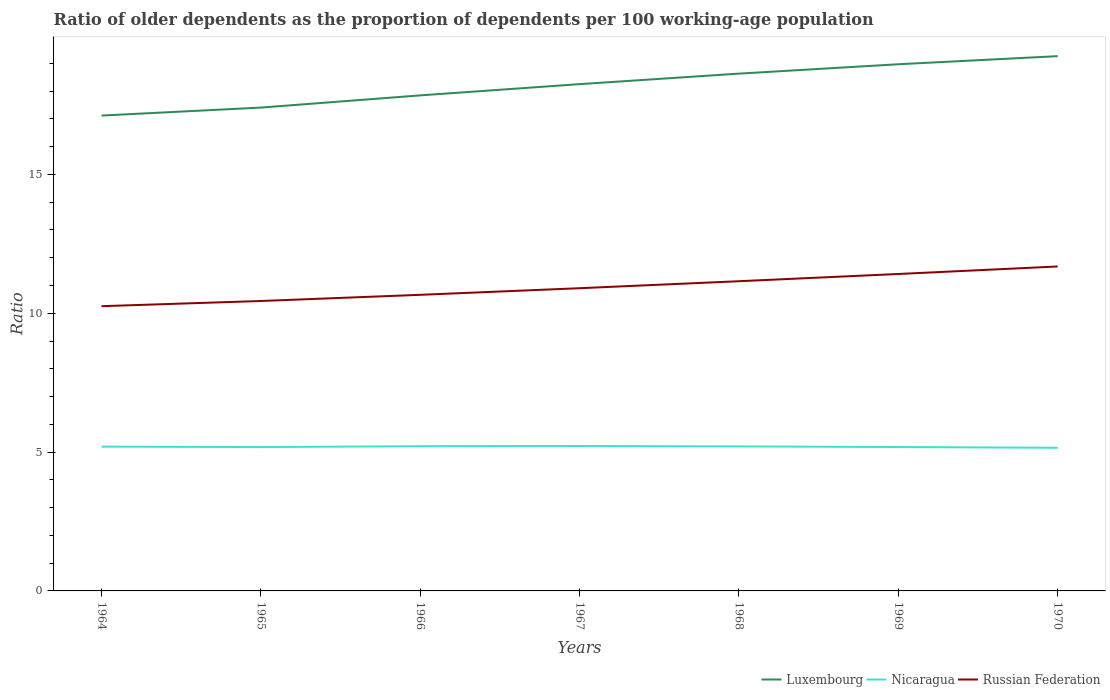How many different coloured lines are there?
Your response must be concise. 3. Does the line corresponding to Nicaragua intersect with the line corresponding to Russian Federation?
Your answer should be compact. No. Is the number of lines equal to the number of legend labels?
Give a very brief answer. Yes. Across all years, what is the maximum age dependency ratio(old) in Russian Federation?
Your answer should be compact. 10.25. In which year was the age dependency ratio(old) in Russian Federation maximum?
Offer a very short reply. 1964. What is the total age dependency ratio(old) in Nicaragua in the graph?
Keep it short and to the point. 0.03. What is the difference between the highest and the second highest age dependency ratio(old) in Luxembourg?
Keep it short and to the point. 2.14. What is the difference between the highest and the lowest age dependency ratio(old) in Russian Federation?
Ensure brevity in your answer.  3. How many lines are there?
Offer a very short reply. 3. What is the difference between two consecutive major ticks on the Y-axis?
Provide a short and direct response. 5. Where does the legend appear in the graph?
Your answer should be very brief. Bottom right. What is the title of the graph?
Your response must be concise. Ratio of older dependents as the proportion of dependents per 100 working-age population. Does "Congo (Democratic)" appear as one of the legend labels in the graph?
Give a very brief answer. No. What is the label or title of the Y-axis?
Offer a terse response. Ratio. What is the Ratio in Luxembourg in 1964?
Keep it short and to the point. 17.12. What is the Ratio of Nicaragua in 1964?
Offer a very short reply. 5.2. What is the Ratio of Russian Federation in 1964?
Make the answer very short. 10.25. What is the Ratio of Luxembourg in 1965?
Provide a succinct answer. 17.41. What is the Ratio of Nicaragua in 1965?
Provide a succinct answer. 5.18. What is the Ratio of Russian Federation in 1965?
Your answer should be compact. 10.44. What is the Ratio in Luxembourg in 1966?
Give a very brief answer. 17.85. What is the Ratio of Nicaragua in 1966?
Ensure brevity in your answer.  5.21. What is the Ratio of Russian Federation in 1966?
Give a very brief answer. 10.66. What is the Ratio in Luxembourg in 1967?
Ensure brevity in your answer.  18.25. What is the Ratio in Nicaragua in 1967?
Make the answer very short. 5.22. What is the Ratio in Russian Federation in 1967?
Offer a terse response. 10.9. What is the Ratio in Luxembourg in 1968?
Offer a very short reply. 18.63. What is the Ratio of Nicaragua in 1968?
Ensure brevity in your answer.  5.21. What is the Ratio in Russian Federation in 1968?
Provide a short and direct response. 11.15. What is the Ratio of Luxembourg in 1969?
Keep it short and to the point. 18.97. What is the Ratio of Nicaragua in 1969?
Give a very brief answer. 5.18. What is the Ratio of Russian Federation in 1969?
Keep it short and to the point. 11.41. What is the Ratio in Luxembourg in 1970?
Ensure brevity in your answer.  19.26. What is the Ratio in Nicaragua in 1970?
Ensure brevity in your answer.  5.16. What is the Ratio in Russian Federation in 1970?
Make the answer very short. 11.69. Across all years, what is the maximum Ratio of Luxembourg?
Make the answer very short. 19.26. Across all years, what is the maximum Ratio of Nicaragua?
Make the answer very short. 5.22. Across all years, what is the maximum Ratio of Russian Federation?
Your response must be concise. 11.69. Across all years, what is the minimum Ratio in Luxembourg?
Keep it short and to the point. 17.12. Across all years, what is the minimum Ratio in Nicaragua?
Keep it short and to the point. 5.16. Across all years, what is the minimum Ratio in Russian Federation?
Provide a succinct answer. 10.25. What is the total Ratio of Luxembourg in the graph?
Keep it short and to the point. 127.49. What is the total Ratio of Nicaragua in the graph?
Offer a very short reply. 36.35. What is the total Ratio of Russian Federation in the graph?
Your response must be concise. 76.52. What is the difference between the Ratio of Luxembourg in 1964 and that in 1965?
Keep it short and to the point. -0.29. What is the difference between the Ratio in Nicaragua in 1964 and that in 1965?
Ensure brevity in your answer.  0.02. What is the difference between the Ratio of Russian Federation in 1964 and that in 1965?
Offer a terse response. -0.19. What is the difference between the Ratio in Luxembourg in 1964 and that in 1966?
Offer a very short reply. -0.73. What is the difference between the Ratio of Nicaragua in 1964 and that in 1966?
Your response must be concise. -0.01. What is the difference between the Ratio of Russian Federation in 1964 and that in 1966?
Your response must be concise. -0.41. What is the difference between the Ratio in Luxembourg in 1964 and that in 1967?
Give a very brief answer. -1.13. What is the difference between the Ratio of Nicaragua in 1964 and that in 1967?
Keep it short and to the point. -0.02. What is the difference between the Ratio of Russian Federation in 1964 and that in 1967?
Your answer should be compact. -0.65. What is the difference between the Ratio of Luxembourg in 1964 and that in 1968?
Offer a terse response. -1.51. What is the difference between the Ratio of Nicaragua in 1964 and that in 1968?
Offer a terse response. -0.01. What is the difference between the Ratio in Russian Federation in 1964 and that in 1968?
Provide a short and direct response. -0.9. What is the difference between the Ratio of Luxembourg in 1964 and that in 1969?
Make the answer very short. -1.85. What is the difference between the Ratio of Nicaragua in 1964 and that in 1969?
Provide a succinct answer. 0.01. What is the difference between the Ratio in Russian Federation in 1964 and that in 1969?
Give a very brief answer. -1.16. What is the difference between the Ratio of Luxembourg in 1964 and that in 1970?
Your response must be concise. -2.14. What is the difference between the Ratio of Nicaragua in 1964 and that in 1970?
Offer a terse response. 0.04. What is the difference between the Ratio of Russian Federation in 1964 and that in 1970?
Your answer should be compact. -1.43. What is the difference between the Ratio in Luxembourg in 1965 and that in 1966?
Offer a very short reply. -0.44. What is the difference between the Ratio in Nicaragua in 1965 and that in 1966?
Provide a short and direct response. -0.03. What is the difference between the Ratio of Russian Federation in 1965 and that in 1966?
Your response must be concise. -0.22. What is the difference between the Ratio in Luxembourg in 1965 and that in 1967?
Your response must be concise. -0.84. What is the difference between the Ratio in Nicaragua in 1965 and that in 1967?
Keep it short and to the point. -0.04. What is the difference between the Ratio of Russian Federation in 1965 and that in 1967?
Offer a very short reply. -0.46. What is the difference between the Ratio of Luxembourg in 1965 and that in 1968?
Offer a very short reply. -1.22. What is the difference between the Ratio of Nicaragua in 1965 and that in 1968?
Provide a succinct answer. -0.02. What is the difference between the Ratio of Russian Federation in 1965 and that in 1968?
Provide a succinct answer. -0.71. What is the difference between the Ratio in Luxembourg in 1965 and that in 1969?
Your answer should be very brief. -1.56. What is the difference between the Ratio in Nicaragua in 1965 and that in 1969?
Offer a very short reply. -0. What is the difference between the Ratio in Russian Federation in 1965 and that in 1969?
Your answer should be very brief. -0.97. What is the difference between the Ratio in Luxembourg in 1965 and that in 1970?
Offer a very short reply. -1.85. What is the difference between the Ratio in Nicaragua in 1965 and that in 1970?
Ensure brevity in your answer.  0.03. What is the difference between the Ratio in Russian Federation in 1965 and that in 1970?
Your answer should be very brief. -1.24. What is the difference between the Ratio in Luxembourg in 1966 and that in 1967?
Keep it short and to the point. -0.4. What is the difference between the Ratio in Nicaragua in 1966 and that in 1967?
Make the answer very short. -0.01. What is the difference between the Ratio of Russian Federation in 1966 and that in 1967?
Your answer should be very brief. -0.24. What is the difference between the Ratio in Luxembourg in 1966 and that in 1968?
Make the answer very short. -0.78. What is the difference between the Ratio in Nicaragua in 1966 and that in 1968?
Your response must be concise. 0.01. What is the difference between the Ratio of Russian Federation in 1966 and that in 1968?
Provide a short and direct response. -0.49. What is the difference between the Ratio in Luxembourg in 1966 and that in 1969?
Provide a succinct answer. -1.12. What is the difference between the Ratio of Nicaragua in 1966 and that in 1969?
Give a very brief answer. 0.03. What is the difference between the Ratio in Russian Federation in 1966 and that in 1969?
Make the answer very short. -0.75. What is the difference between the Ratio in Luxembourg in 1966 and that in 1970?
Keep it short and to the point. -1.41. What is the difference between the Ratio of Nicaragua in 1966 and that in 1970?
Your answer should be very brief. 0.06. What is the difference between the Ratio in Russian Federation in 1966 and that in 1970?
Ensure brevity in your answer.  -1.02. What is the difference between the Ratio of Luxembourg in 1967 and that in 1968?
Provide a short and direct response. -0.38. What is the difference between the Ratio in Nicaragua in 1967 and that in 1968?
Your response must be concise. 0.01. What is the difference between the Ratio of Russian Federation in 1967 and that in 1968?
Your response must be concise. -0.25. What is the difference between the Ratio in Luxembourg in 1967 and that in 1969?
Provide a short and direct response. -0.72. What is the difference between the Ratio of Nicaragua in 1967 and that in 1969?
Ensure brevity in your answer.  0.04. What is the difference between the Ratio of Russian Federation in 1967 and that in 1969?
Offer a very short reply. -0.51. What is the difference between the Ratio of Luxembourg in 1967 and that in 1970?
Provide a short and direct response. -1.01. What is the difference between the Ratio of Nicaragua in 1967 and that in 1970?
Give a very brief answer. 0.06. What is the difference between the Ratio in Russian Federation in 1967 and that in 1970?
Provide a succinct answer. -0.78. What is the difference between the Ratio of Luxembourg in 1968 and that in 1969?
Your answer should be compact. -0.34. What is the difference between the Ratio in Nicaragua in 1968 and that in 1969?
Your response must be concise. 0.02. What is the difference between the Ratio of Russian Federation in 1968 and that in 1969?
Offer a terse response. -0.26. What is the difference between the Ratio in Luxembourg in 1968 and that in 1970?
Give a very brief answer. -0.63. What is the difference between the Ratio of Nicaragua in 1968 and that in 1970?
Provide a succinct answer. 0.05. What is the difference between the Ratio of Russian Federation in 1968 and that in 1970?
Offer a terse response. -0.53. What is the difference between the Ratio of Luxembourg in 1969 and that in 1970?
Your response must be concise. -0.29. What is the difference between the Ratio of Nicaragua in 1969 and that in 1970?
Provide a short and direct response. 0.03. What is the difference between the Ratio of Russian Federation in 1969 and that in 1970?
Keep it short and to the point. -0.27. What is the difference between the Ratio of Luxembourg in 1964 and the Ratio of Nicaragua in 1965?
Offer a terse response. 11.94. What is the difference between the Ratio of Luxembourg in 1964 and the Ratio of Russian Federation in 1965?
Your answer should be very brief. 6.68. What is the difference between the Ratio of Nicaragua in 1964 and the Ratio of Russian Federation in 1965?
Offer a terse response. -5.24. What is the difference between the Ratio of Luxembourg in 1964 and the Ratio of Nicaragua in 1966?
Provide a short and direct response. 11.91. What is the difference between the Ratio of Luxembourg in 1964 and the Ratio of Russian Federation in 1966?
Give a very brief answer. 6.46. What is the difference between the Ratio in Nicaragua in 1964 and the Ratio in Russian Federation in 1966?
Make the answer very short. -5.47. What is the difference between the Ratio in Luxembourg in 1964 and the Ratio in Nicaragua in 1967?
Your answer should be very brief. 11.9. What is the difference between the Ratio in Luxembourg in 1964 and the Ratio in Russian Federation in 1967?
Offer a very short reply. 6.22. What is the difference between the Ratio of Nicaragua in 1964 and the Ratio of Russian Federation in 1967?
Offer a very short reply. -5.71. What is the difference between the Ratio of Luxembourg in 1964 and the Ratio of Nicaragua in 1968?
Make the answer very short. 11.91. What is the difference between the Ratio of Luxembourg in 1964 and the Ratio of Russian Federation in 1968?
Offer a very short reply. 5.97. What is the difference between the Ratio in Nicaragua in 1964 and the Ratio in Russian Federation in 1968?
Offer a terse response. -5.96. What is the difference between the Ratio of Luxembourg in 1964 and the Ratio of Nicaragua in 1969?
Offer a terse response. 11.94. What is the difference between the Ratio in Luxembourg in 1964 and the Ratio in Russian Federation in 1969?
Your answer should be compact. 5.71. What is the difference between the Ratio in Nicaragua in 1964 and the Ratio in Russian Federation in 1969?
Make the answer very short. -6.22. What is the difference between the Ratio of Luxembourg in 1964 and the Ratio of Nicaragua in 1970?
Make the answer very short. 11.96. What is the difference between the Ratio in Luxembourg in 1964 and the Ratio in Russian Federation in 1970?
Keep it short and to the point. 5.43. What is the difference between the Ratio in Nicaragua in 1964 and the Ratio in Russian Federation in 1970?
Offer a very short reply. -6.49. What is the difference between the Ratio of Luxembourg in 1965 and the Ratio of Nicaragua in 1966?
Offer a terse response. 12.2. What is the difference between the Ratio of Luxembourg in 1965 and the Ratio of Russian Federation in 1966?
Offer a very short reply. 6.74. What is the difference between the Ratio of Nicaragua in 1965 and the Ratio of Russian Federation in 1966?
Your answer should be compact. -5.48. What is the difference between the Ratio of Luxembourg in 1965 and the Ratio of Nicaragua in 1967?
Your response must be concise. 12.19. What is the difference between the Ratio of Luxembourg in 1965 and the Ratio of Russian Federation in 1967?
Keep it short and to the point. 6.51. What is the difference between the Ratio in Nicaragua in 1965 and the Ratio in Russian Federation in 1967?
Give a very brief answer. -5.72. What is the difference between the Ratio in Luxembourg in 1965 and the Ratio in Nicaragua in 1968?
Keep it short and to the point. 12.2. What is the difference between the Ratio of Luxembourg in 1965 and the Ratio of Russian Federation in 1968?
Offer a terse response. 6.25. What is the difference between the Ratio of Nicaragua in 1965 and the Ratio of Russian Federation in 1968?
Make the answer very short. -5.97. What is the difference between the Ratio in Luxembourg in 1965 and the Ratio in Nicaragua in 1969?
Provide a succinct answer. 12.23. What is the difference between the Ratio in Luxembourg in 1965 and the Ratio in Russian Federation in 1969?
Keep it short and to the point. 5.99. What is the difference between the Ratio in Nicaragua in 1965 and the Ratio in Russian Federation in 1969?
Offer a terse response. -6.23. What is the difference between the Ratio in Luxembourg in 1965 and the Ratio in Nicaragua in 1970?
Keep it short and to the point. 12.25. What is the difference between the Ratio in Luxembourg in 1965 and the Ratio in Russian Federation in 1970?
Provide a succinct answer. 5.72. What is the difference between the Ratio of Nicaragua in 1965 and the Ratio of Russian Federation in 1970?
Provide a succinct answer. -6.5. What is the difference between the Ratio of Luxembourg in 1966 and the Ratio of Nicaragua in 1967?
Provide a succinct answer. 12.63. What is the difference between the Ratio of Luxembourg in 1966 and the Ratio of Russian Federation in 1967?
Provide a short and direct response. 6.94. What is the difference between the Ratio in Nicaragua in 1966 and the Ratio in Russian Federation in 1967?
Make the answer very short. -5.69. What is the difference between the Ratio in Luxembourg in 1966 and the Ratio in Nicaragua in 1968?
Provide a short and direct response. 12.64. What is the difference between the Ratio in Luxembourg in 1966 and the Ratio in Russian Federation in 1968?
Ensure brevity in your answer.  6.69. What is the difference between the Ratio in Nicaragua in 1966 and the Ratio in Russian Federation in 1968?
Keep it short and to the point. -5.94. What is the difference between the Ratio of Luxembourg in 1966 and the Ratio of Nicaragua in 1969?
Provide a succinct answer. 12.66. What is the difference between the Ratio in Luxembourg in 1966 and the Ratio in Russian Federation in 1969?
Ensure brevity in your answer.  6.43. What is the difference between the Ratio of Nicaragua in 1966 and the Ratio of Russian Federation in 1969?
Offer a terse response. -6.2. What is the difference between the Ratio of Luxembourg in 1966 and the Ratio of Nicaragua in 1970?
Offer a very short reply. 12.69. What is the difference between the Ratio in Luxembourg in 1966 and the Ratio in Russian Federation in 1970?
Your answer should be very brief. 6.16. What is the difference between the Ratio in Nicaragua in 1966 and the Ratio in Russian Federation in 1970?
Your answer should be compact. -6.47. What is the difference between the Ratio in Luxembourg in 1967 and the Ratio in Nicaragua in 1968?
Provide a short and direct response. 13.05. What is the difference between the Ratio in Luxembourg in 1967 and the Ratio in Russian Federation in 1968?
Your response must be concise. 7.1. What is the difference between the Ratio of Nicaragua in 1967 and the Ratio of Russian Federation in 1968?
Keep it short and to the point. -5.94. What is the difference between the Ratio in Luxembourg in 1967 and the Ratio in Nicaragua in 1969?
Ensure brevity in your answer.  13.07. What is the difference between the Ratio of Luxembourg in 1967 and the Ratio of Russian Federation in 1969?
Ensure brevity in your answer.  6.84. What is the difference between the Ratio of Nicaragua in 1967 and the Ratio of Russian Federation in 1969?
Provide a short and direct response. -6.2. What is the difference between the Ratio in Luxembourg in 1967 and the Ratio in Nicaragua in 1970?
Offer a terse response. 13.1. What is the difference between the Ratio of Luxembourg in 1967 and the Ratio of Russian Federation in 1970?
Your answer should be very brief. 6.57. What is the difference between the Ratio of Nicaragua in 1967 and the Ratio of Russian Federation in 1970?
Your answer should be very brief. -6.47. What is the difference between the Ratio of Luxembourg in 1968 and the Ratio of Nicaragua in 1969?
Your answer should be very brief. 13.45. What is the difference between the Ratio of Luxembourg in 1968 and the Ratio of Russian Federation in 1969?
Offer a terse response. 7.22. What is the difference between the Ratio in Nicaragua in 1968 and the Ratio in Russian Federation in 1969?
Your answer should be very brief. -6.21. What is the difference between the Ratio of Luxembourg in 1968 and the Ratio of Nicaragua in 1970?
Make the answer very short. 13.48. What is the difference between the Ratio in Luxembourg in 1968 and the Ratio in Russian Federation in 1970?
Provide a succinct answer. 6.95. What is the difference between the Ratio in Nicaragua in 1968 and the Ratio in Russian Federation in 1970?
Offer a terse response. -6.48. What is the difference between the Ratio in Luxembourg in 1969 and the Ratio in Nicaragua in 1970?
Ensure brevity in your answer.  13.81. What is the difference between the Ratio in Luxembourg in 1969 and the Ratio in Russian Federation in 1970?
Provide a short and direct response. 7.28. What is the difference between the Ratio in Nicaragua in 1969 and the Ratio in Russian Federation in 1970?
Give a very brief answer. -6.5. What is the average Ratio of Luxembourg per year?
Your response must be concise. 18.21. What is the average Ratio of Nicaragua per year?
Your answer should be compact. 5.19. What is the average Ratio in Russian Federation per year?
Offer a terse response. 10.93. In the year 1964, what is the difference between the Ratio in Luxembourg and Ratio in Nicaragua?
Your answer should be very brief. 11.92. In the year 1964, what is the difference between the Ratio of Luxembourg and Ratio of Russian Federation?
Your response must be concise. 6.87. In the year 1964, what is the difference between the Ratio in Nicaragua and Ratio in Russian Federation?
Provide a succinct answer. -5.06. In the year 1965, what is the difference between the Ratio in Luxembourg and Ratio in Nicaragua?
Your answer should be compact. 12.23. In the year 1965, what is the difference between the Ratio of Luxembourg and Ratio of Russian Federation?
Your answer should be compact. 6.97. In the year 1965, what is the difference between the Ratio of Nicaragua and Ratio of Russian Federation?
Your answer should be very brief. -5.26. In the year 1966, what is the difference between the Ratio of Luxembourg and Ratio of Nicaragua?
Make the answer very short. 12.64. In the year 1966, what is the difference between the Ratio in Luxembourg and Ratio in Russian Federation?
Ensure brevity in your answer.  7.18. In the year 1966, what is the difference between the Ratio of Nicaragua and Ratio of Russian Federation?
Provide a short and direct response. -5.45. In the year 1967, what is the difference between the Ratio in Luxembourg and Ratio in Nicaragua?
Your answer should be very brief. 13.03. In the year 1967, what is the difference between the Ratio in Luxembourg and Ratio in Russian Federation?
Your answer should be very brief. 7.35. In the year 1967, what is the difference between the Ratio in Nicaragua and Ratio in Russian Federation?
Offer a very short reply. -5.68. In the year 1968, what is the difference between the Ratio of Luxembourg and Ratio of Nicaragua?
Your response must be concise. 13.43. In the year 1968, what is the difference between the Ratio in Luxembourg and Ratio in Russian Federation?
Your answer should be compact. 7.48. In the year 1968, what is the difference between the Ratio of Nicaragua and Ratio of Russian Federation?
Keep it short and to the point. -5.95. In the year 1969, what is the difference between the Ratio in Luxembourg and Ratio in Nicaragua?
Provide a short and direct response. 13.79. In the year 1969, what is the difference between the Ratio of Luxembourg and Ratio of Russian Federation?
Your answer should be very brief. 7.55. In the year 1969, what is the difference between the Ratio of Nicaragua and Ratio of Russian Federation?
Make the answer very short. -6.23. In the year 1970, what is the difference between the Ratio in Luxembourg and Ratio in Nicaragua?
Offer a very short reply. 14.1. In the year 1970, what is the difference between the Ratio of Luxembourg and Ratio of Russian Federation?
Your response must be concise. 7.57. In the year 1970, what is the difference between the Ratio in Nicaragua and Ratio in Russian Federation?
Your answer should be compact. -6.53. What is the ratio of the Ratio in Luxembourg in 1964 to that in 1965?
Make the answer very short. 0.98. What is the ratio of the Ratio in Nicaragua in 1964 to that in 1965?
Make the answer very short. 1. What is the ratio of the Ratio of Russian Federation in 1964 to that in 1965?
Keep it short and to the point. 0.98. What is the ratio of the Ratio of Luxembourg in 1964 to that in 1966?
Your answer should be very brief. 0.96. What is the ratio of the Ratio of Nicaragua in 1964 to that in 1966?
Offer a terse response. 1. What is the ratio of the Ratio in Russian Federation in 1964 to that in 1966?
Offer a very short reply. 0.96. What is the ratio of the Ratio in Luxembourg in 1964 to that in 1967?
Give a very brief answer. 0.94. What is the ratio of the Ratio of Nicaragua in 1964 to that in 1967?
Give a very brief answer. 1. What is the ratio of the Ratio in Russian Federation in 1964 to that in 1967?
Your answer should be very brief. 0.94. What is the ratio of the Ratio in Luxembourg in 1964 to that in 1968?
Your answer should be very brief. 0.92. What is the ratio of the Ratio in Nicaragua in 1964 to that in 1968?
Your answer should be very brief. 1. What is the ratio of the Ratio of Russian Federation in 1964 to that in 1968?
Ensure brevity in your answer.  0.92. What is the ratio of the Ratio in Luxembourg in 1964 to that in 1969?
Make the answer very short. 0.9. What is the ratio of the Ratio of Russian Federation in 1964 to that in 1969?
Offer a very short reply. 0.9. What is the ratio of the Ratio of Nicaragua in 1964 to that in 1970?
Your answer should be very brief. 1.01. What is the ratio of the Ratio of Russian Federation in 1964 to that in 1970?
Give a very brief answer. 0.88. What is the ratio of the Ratio in Luxembourg in 1965 to that in 1966?
Make the answer very short. 0.98. What is the ratio of the Ratio of Nicaragua in 1965 to that in 1966?
Offer a terse response. 0.99. What is the ratio of the Ratio in Russian Federation in 1965 to that in 1966?
Your response must be concise. 0.98. What is the ratio of the Ratio in Luxembourg in 1965 to that in 1967?
Provide a succinct answer. 0.95. What is the ratio of the Ratio in Nicaragua in 1965 to that in 1967?
Provide a short and direct response. 0.99. What is the ratio of the Ratio in Russian Federation in 1965 to that in 1967?
Give a very brief answer. 0.96. What is the ratio of the Ratio of Luxembourg in 1965 to that in 1968?
Provide a short and direct response. 0.93. What is the ratio of the Ratio of Russian Federation in 1965 to that in 1968?
Your response must be concise. 0.94. What is the ratio of the Ratio of Luxembourg in 1965 to that in 1969?
Keep it short and to the point. 0.92. What is the ratio of the Ratio in Russian Federation in 1965 to that in 1969?
Keep it short and to the point. 0.91. What is the ratio of the Ratio in Luxembourg in 1965 to that in 1970?
Provide a short and direct response. 0.9. What is the ratio of the Ratio in Nicaragua in 1965 to that in 1970?
Keep it short and to the point. 1.01. What is the ratio of the Ratio of Russian Federation in 1965 to that in 1970?
Offer a terse response. 0.89. What is the ratio of the Ratio of Luxembourg in 1966 to that in 1967?
Keep it short and to the point. 0.98. What is the ratio of the Ratio in Russian Federation in 1966 to that in 1967?
Make the answer very short. 0.98. What is the ratio of the Ratio in Luxembourg in 1966 to that in 1968?
Give a very brief answer. 0.96. What is the ratio of the Ratio in Russian Federation in 1966 to that in 1968?
Your answer should be very brief. 0.96. What is the ratio of the Ratio of Luxembourg in 1966 to that in 1969?
Your answer should be very brief. 0.94. What is the ratio of the Ratio of Russian Federation in 1966 to that in 1969?
Your answer should be compact. 0.93. What is the ratio of the Ratio in Luxembourg in 1966 to that in 1970?
Your answer should be very brief. 0.93. What is the ratio of the Ratio of Nicaragua in 1966 to that in 1970?
Provide a short and direct response. 1.01. What is the ratio of the Ratio of Russian Federation in 1966 to that in 1970?
Offer a terse response. 0.91. What is the ratio of the Ratio in Luxembourg in 1967 to that in 1968?
Keep it short and to the point. 0.98. What is the ratio of the Ratio of Nicaragua in 1967 to that in 1968?
Ensure brevity in your answer.  1. What is the ratio of the Ratio in Russian Federation in 1967 to that in 1968?
Your answer should be very brief. 0.98. What is the ratio of the Ratio in Luxembourg in 1967 to that in 1969?
Your answer should be very brief. 0.96. What is the ratio of the Ratio of Nicaragua in 1967 to that in 1969?
Offer a terse response. 1.01. What is the ratio of the Ratio of Russian Federation in 1967 to that in 1969?
Your answer should be very brief. 0.96. What is the ratio of the Ratio of Luxembourg in 1967 to that in 1970?
Make the answer very short. 0.95. What is the ratio of the Ratio in Nicaragua in 1967 to that in 1970?
Offer a very short reply. 1.01. What is the ratio of the Ratio in Russian Federation in 1967 to that in 1970?
Offer a terse response. 0.93. What is the ratio of the Ratio in Luxembourg in 1968 to that in 1969?
Make the answer very short. 0.98. What is the ratio of the Ratio of Nicaragua in 1968 to that in 1969?
Give a very brief answer. 1. What is the ratio of the Ratio of Russian Federation in 1968 to that in 1969?
Provide a succinct answer. 0.98. What is the ratio of the Ratio of Luxembourg in 1968 to that in 1970?
Your response must be concise. 0.97. What is the ratio of the Ratio in Nicaragua in 1968 to that in 1970?
Ensure brevity in your answer.  1.01. What is the ratio of the Ratio in Russian Federation in 1968 to that in 1970?
Provide a short and direct response. 0.95. What is the ratio of the Ratio of Luxembourg in 1969 to that in 1970?
Keep it short and to the point. 0.98. What is the ratio of the Ratio of Russian Federation in 1969 to that in 1970?
Provide a succinct answer. 0.98. What is the difference between the highest and the second highest Ratio of Luxembourg?
Make the answer very short. 0.29. What is the difference between the highest and the second highest Ratio of Nicaragua?
Make the answer very short. 0.01. What is the difference between the highest and the second highest Ratio of Russian Federation?
Make the answer very short. 0.27. What is the difference between the highest and the lowest Ratio of Luxembourg?
Make the answer very short. 2.14. What is the difference between the highest and the lowest Ratio of Nicaragua?
Provide a short and direct response. 0.06. What is the difference between the highest and the lowest Ratio of Russian Federation?
Provide a succinct answer. 1.43. 